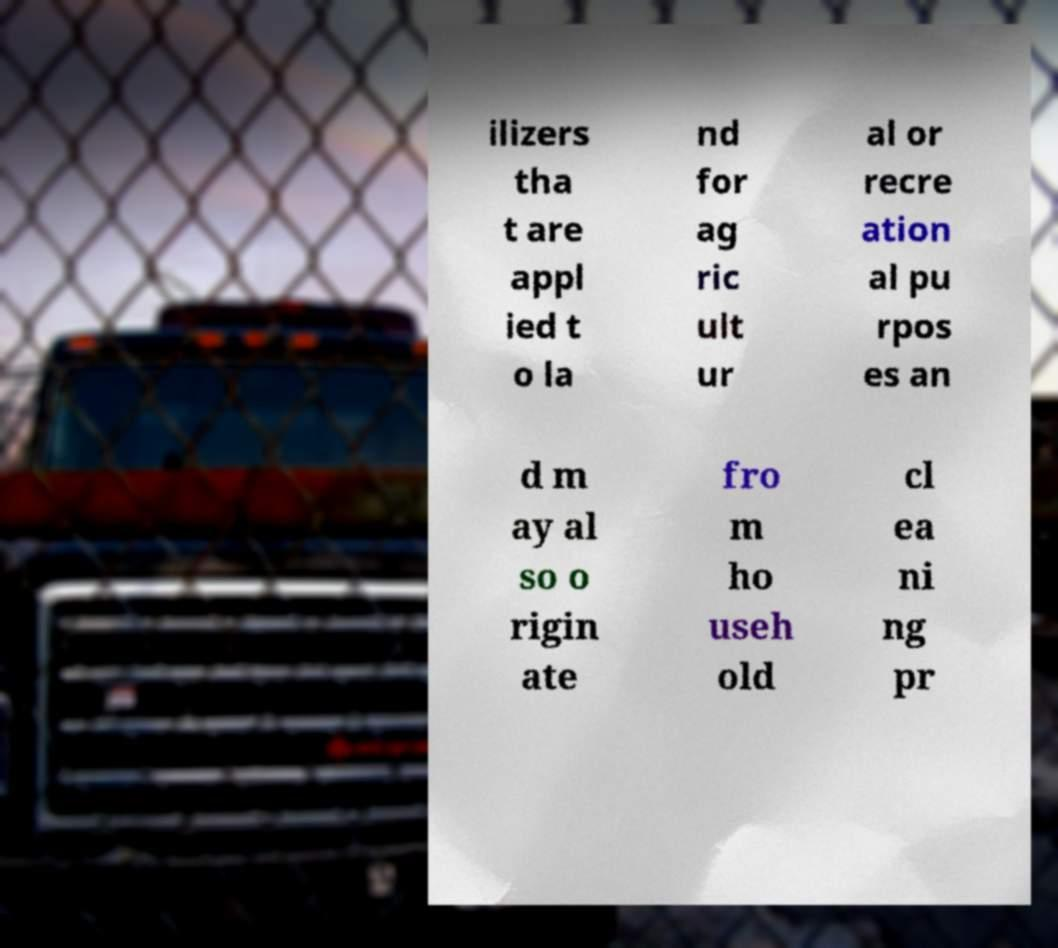Can you accurately transcribe the text from the provided image for me? ilizers tha t are appl ied t o la nd for ag ric ult ur al or recre ation al pu rpos es an d m ay al so o rigin ate fro m ho useh old cl ea ni ng pr 